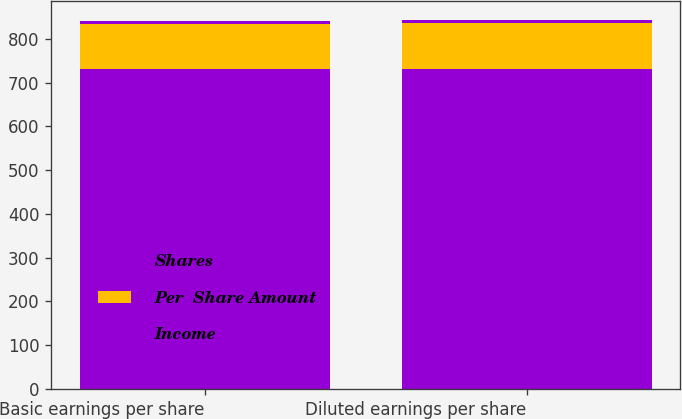Convert chart. <chart><loc_0><loc_0><loc_500><loc_500><stacked_bar_chart><ecel><fcel>Basic earnings per share<fcel>Diluted earnings per share<nl><fcel>Shares<fcel>732.1<fcel>732.1<nl><fcel>Per  Share Amount<fcel>102.5<fcel>104.3<nl><fcel>Income<fcel>7.14<fcel>7.02<nl></chart> 